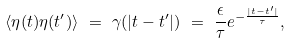<formula> <loc_0><loc_0><loc_500><loc_500>\langle \eta ( t ) \eta ( t ^ { \prime } ) \rangle \ = \ \gamma ( | t - t ^ { \prime } | ) \ = \ \frac { \epsilon } { \tau } e ^ { - \frac { | t - t ^ { \prime } | } { \tau } } ,</formula> 